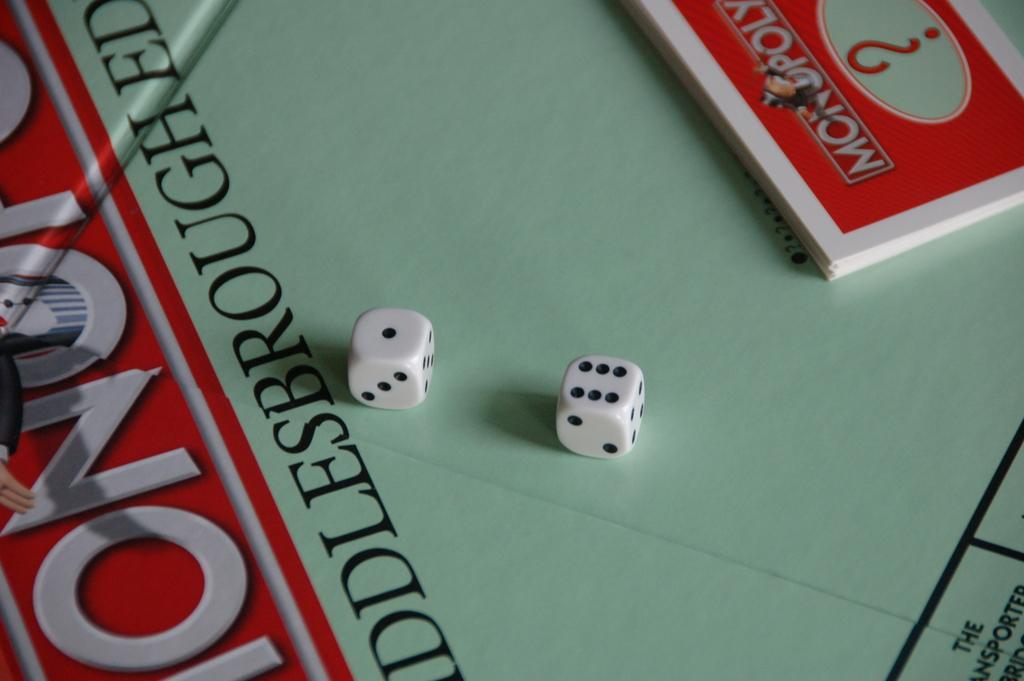Please provide a concise description of this image. In this picture there are two dices and there are cards. At the bottom it looks like a board and there is a text and there is a picture of a person on the board. 